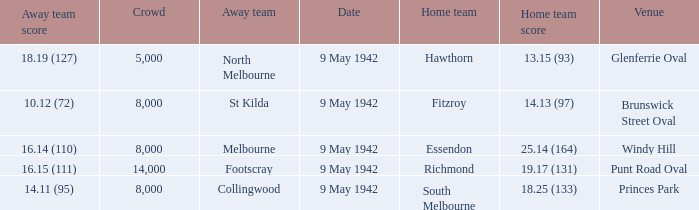How large was the crowd with a home team score of 18.25 (133)? 8000.0. 